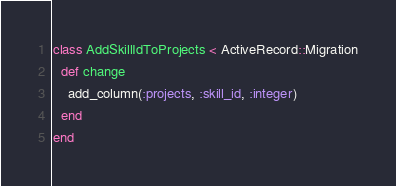Convert code to text. <code><loc_0><loc_0><loc_500><loc_500><_Ruby_>class AddSkillIdToProjects < ActiveRecord::Migration
  def change
    add_column(:projects, :skill_id, :integer)
  end
end
</code> 